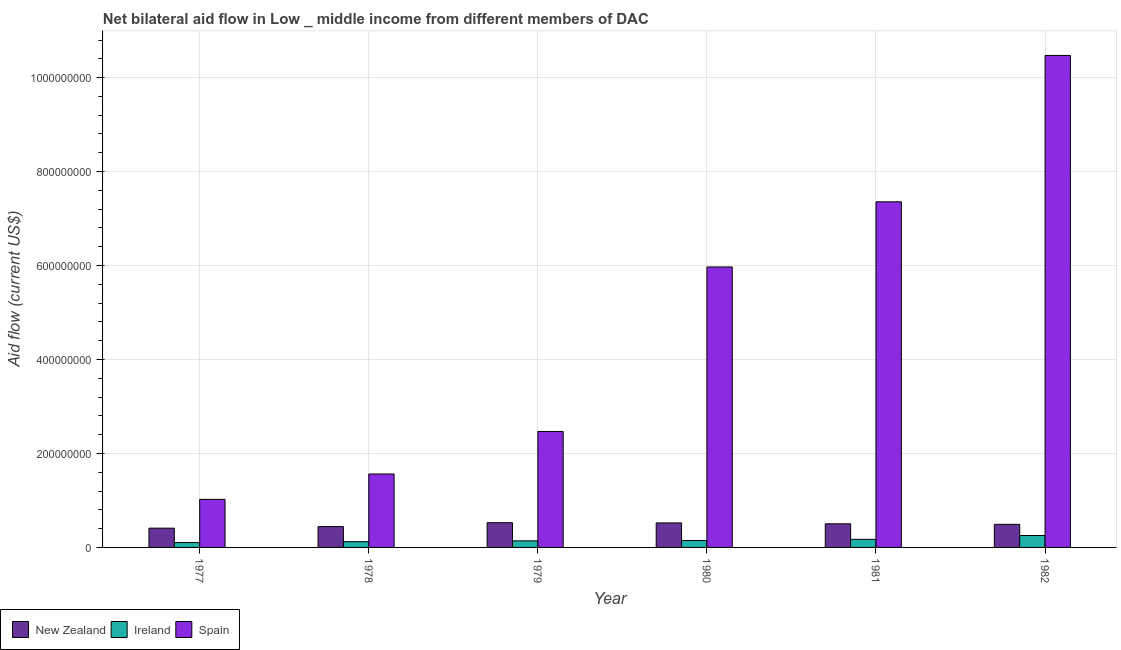How many different coloured bars are there?
Your response must be concise. 3. What is the label of the 5th group of bars from the left?
Offer a very short reply. 1981. What is the amount of aid provided by ireland in 1978?
Your answer should be very brief. 1.22e+07. Across all years, what is the maximum amount of aid provided by new zealand?
Offer a very short reply. 5.27e+07. Across all years, what is the minimum amount of aid provided by new zealand?
Ensure brevity in your answer.  4.10e+07. In which year was the amount of aid provided by new zealand maximum?
Make the answer very short. 1979. What is the total amount of aid provided by ireland in the graph?
Provide a succinct answer. 9.37e+07. What is the difference between the amount of aid provided by ireland in 1979 and that in 1980?
Offer a terse response. -6.70e+05. What is the difference between the amount of aid provided by new zealand in 1981 and the amount of aid provided by ireland in 1979?
Give a very brief answer. -2.37e+06. What is the average amount of aid provided by new zealand per year?
Ensure brevity in your answer.  4.83e+07. What is the ratio of the amount of aid provided by new zealand in 1978 to that in 1980?
Your answer should be compact. 0.85. What is the difference between the highest and the second highest amount of aid provided by new zealand?
Keep it short and to the point. 5.00e+05. What is the difference between the highest and the lowest amount of aid provided by ireland?
Provide a short and direct response. 1.49e+07. How many bars are there?
Ensure brevity in your answer.  18. Are all the bars in the graph horizontal?
Your answer should be very brief. No. How many years are there in the graph?
Ensure brevity in your answer.  6. Are the values on the major ticks of Y-axis written in scientific E-notation?
Keep it short and to the point. No. Does the graph contain grids?
Offer a terse response. Yes. Where does the legend appear in the graph?
Provide a succinct answer. Bottom left. What is the title of the graph?
Provide a succinct answer. Net bilateral aid flow in Low _ middle income from different members of DAC. What is the label or title of the X-axis?
Offer a very short reply. Year. What is the Aid flow (current US$) of New Zealand in 1977?
Offer a terse response. 4.10e+07. What is the Aid flow (current US$) in Ireland in 1977?
Give a very brief answer. 1.04e+07. What is the Aid flow (current US$) of Spain in 1977?
Offer a terse response. 1.02e+08. What is the Aid flow (current US$) in New Zealand in 1978?
Offer a terse response. 4.43e+07. What is the Aid flow (current US$) in Ireland in 1978?
Your answer should be compact. 1.22e+07. What is the Aid flow (current US$) of Spain in 1978?
Ensure brevity in your answer.  1.56e+08. What is the Aid flow (current US$) in New Zealand in 1979?
Give a very brief answer. 5.27e+07. What is the Aid flow (current US$) in Ireland in 1979?
Offer a very short reply. 1.40e+07. What is the Aid flow (current US$) in Spain in 1979?
Your answer should be very brief. 2.47e+08. What is the Aid flow (current US$) of New Zealand in 1980?
Keep it short and to the point. 5.22e+07. What is the Aid flow (current US$) in Ireland in 1980?
Your response must be concise. 1.46e+07. What is the Aid flow (current US$) of Spain in 1980?
Offer a terse response. 5.97e+08. What is the Aid flow (current US$) in New Zealand in 1981?
Provide a short and direct response. 5.03e+07. What is the Aid flow (current US$) in Ireland in 1981?
Your answer should be very brief. 1.72e+07. What is the Aid flow (current US$) of Spain in 1981?
Give a very brief answer. 7.36e+08. What is the Aid flow (current US$) of New Zealand in 1982?
Your response must be concise. 4.91e+07. What is the Aid flow (current US$) in Ireland in 1982?
Your answer should be compact. 2.53e+07. What is the Aid flow (current US$) of Spain in 1982?
Make the answer very short. 1.05e+09. Across all years, what is the maximum Aid flow (current US$) of New Zealand?
Give a very brief answer. 5.27e+07. Across all years, what is the maximum Aid flow (current US$) of Ireland?
Keep it short and to the point. 2.53e+07. Across all years, what is the maximum Aid flow (current US$) in Spain?
Make the answer very short. 1.05e+09. Across all years, what is the minimum Aid flow (current US$) in New Zealand?
Keep it short and to the point. 4.10e+07. Across all years, what is the minimum Aid flow (current US$) in Ireland?
Keep it short and to the point. 1.04e+07. Across all years, what is the minimum Aid flow (current US$) of Spain?
Your answer should be compact. 1.02e+08. What is the total Aid flow (current US$) of New Zealand in the graph?
Provide a short and direct response. 2.90e+08. What is the total Aid flow (current US$) in Ireland in the graph?
Give a very brief answer. 9.37e+07. What is the total Aid flow (current US$) in Spain in the graph?
Keep it short and to the point. 2.89e+09. What is the difference between the Aid flow (current US$) of New Zealand in 1977 and that in 1978?
Your response must be concise. -3.28e+06. What is the difference between the Aid flow (current US$) in Ireland in 1977 and that in 1978?
Ensure brevity in your answer.  -1.87e+06. What is the difference between the Aid flow (current US$) in Spain in 1977 and that in 1978?
Offer a terse response. -5.40e+07. What is the difference between the Aid flow (current US$) of New Zealand in 1977 and that in 1979?
Ensure brevity in your answer.  -1.17e+07. What is the difference between the Aid flow (current US$) in Ireland in 1977 and that in 1979?
Offer a very short reply. -3.61e+06. What is the difference between the Aid flow (current US$) of Spain in 1977 and that in 1979?
Offer a terse response. -1.45e+08. What is the difference between the Aid flow (current US$) in New Zealand in 1977 and that in 1980?
Keep it short and to the point. -1.12e+07. What is the difference between the Aid flow (current US$) in Ireland in 1977 and that in 1980?
Make the answer very short. -4.28e+06. What is the difference between the Aid flow (current US$) in Spain in 1977 and that in 1980?
Offer a terse response. -4.95e+08. What is the difference between the Aid flow (current US$) of New Zealand in 1977 and that in 1981?
Provide a short and direct response. -9.29e+06. What is the difference between the Aid flow (current US$) of Ireland in 1977 and that in 1981?
Offer a very short reply. -6.87e+06. What is the difference between the Aid flow (current US$) of Spain in 1977 and that in 1981?
Provide a short and direct response. -6.33e+08. What is the difference between the Aid flow (current US$) in New Zealand in 1977 and that in 1982?
Provide a succinct answer. -8.13e+06. What is the difference between the Aid flow (current US$) of Ireland in 1977 and that in 1982?
Keep it short and to the point. -1.49e+07. What is the difference between the Aid flow (current US$) in Spain in 1977 and that in 1982?
Offer a very short reply. -9.45e+08. What is the difference between the Aid flow (current US$) of New Zealand in 1978 and that in 1979?
Ensure brevity in your answer.  -8.38e+06. What is the difference between the Aid flow (current US$) of Ireland in 1978 and that in 1979?
Provide a short and direct response. -1.74e+06. What is the difference between the Aid flow (current US$) in Spain in 1978 and that in 1979?
Provide a succinct answer. -9.05e+07. What is the difference between the Aid flow (current US$) of New Zealand in 1978 and that in 1980?
Provide a short and direct response. -7.88e+06. What is the difference between the Aid flow (current US$) of Ireland in 1978 and that in 1980?
Ensure brevity in your answer.  -2.41e+06. What is the difference between the Aid flow (current US$) in Spain in 1978 and that in 1980?
Provide a short and direct response. -4.41e+08. What is the difference between the Aid flow (current US$) in New Zealand in 1978 and that in 1981?
Provide a short and direct response. -6.01e+06. What is the difference between the Aid flow (current US$) in Ireland in 1978 and that in 1981?
Your answer should be very brief. -5.00e+06. What is the difference between the Aid flow (current US$) of Spain in 1978 and that in 1981?
Make the answer very short. -5.79e+08. What is the difference between the Aid flow (current US$) in New Zealand in 1978 and that in 1982?
Offer a terse response. -4.85e+06. What is the difference between the Aid flow (current US$) of Ireland in 1978 and that in 1982?
Give a very brief answer. -1.31e+07. What is the difference between the Aid flow (current US$) in Spain in 1978 and that in 1982?
Keep it short and to the point. -8.91e+08. What is the difference between the Aid flow (current US$) of Ireland in 1979 and that in 1980?
Keep it short and to the point. -6.70e+05. What is the difference between the Aid flow (current US$) in Spain in 1979 and that in 1980?
Give a very brief answer. -3.50e+08. What is the difference between the Aid flow (current US$) of New Zealand in 1979 and that in 1981?
Provide a succinct answer. 2.37e+06. What is the difference between the Aid flow (current US$) in Ireland in 1979 and that in 1981?
Offer a terse response. -3.26e+06. What is the difference between the Aid flow (current US$) in Spain in 1979 and that in 1981?
Keep it short and to the point. -4.89e+08. What is the difference between the Aid flow (current US$) of New Zealand in 1979 and that in 1982?
Make the answer very short. 3.53e+06. What is the difference between the Aid flow (current US$) in Ireland in 1979 and that in 1982?
Your answer should be compact. -1.13e+07. What is the difference between the Aid flow (current US$) of Spain in 1979 and that in 1982?
Offer a terse response. -8.00e+08. What is the difference between the Aid flow (current US$) of New Zealand in 1980 and that in 1981?
Offer a terse response. 1.87e+06. What is the difference between the Aid flow (current US$) of Ireland in 1980 and that in 1981?
Offer a very short reply. -2.59e+06. What is the difference between the Aid flow (current US$) in Spain in 1980 and that in 1981?
Provide a short and direct response. -1.39e+08. What is the difference between the Aid flow (current US$) of New Zealand in 1980 and that in 1982?
Make the answer very short. 3.03e+06. What is the difference between the Aid flow (current US$) in Ireland in 1980 and that in 1982?
Your answer should be compact. -1.07e+07. What is the difference between the Aid flow (current US$) in Spain in 1980 and that in 1982?
Provide a short and direct response. -4.50e+08. What is the difference between the Aid flow (current US$) in New Zealand in 1981 and that in 1982?
Ensure brevity in your answer.  1.16e+06. What is the difference between the Aid flow (current US$) of Ireland in 1981 and that in 1982?
Make the answer very short. -8.07e+06. What is the difference between the Aid flow (current US$) of Spain in 1981 and that in 1982?
Your answer should be compact. -3.12e+08. What is the difference between the Aid flow (current US$) in New Zealand in 1977 and the Aid flow (current US$) in Ireland in 1978?
Ensure brevity in your answer.  2.88e+07. What is the difference between the Aid flow (current US$) in New Zealand in 1977 and the Aid flow (current US$) in Spain in 1978?
Provide a short and direct response. -1.15e+08. What is the difference between the Aid flow (current US$) of Ireland in 1977 and the Aid flow (current US$) of Spain in 1978?
Your response must be concise. -1.46e+08. What is the difference between the Aid flow (current US$) in New Zealand in 1977 and the Aid flow (current US$) in Ireland in 1979?
Your response must be concise. 2.70e+07. What is the difference between the Aid flow (current US$) of New Zealand in 1977 and the Aid flow (current US$) of Spain in 1979?
Provide a short and direct response. -2.06e+08. What is the difference between the Aid flow (current US$) of Ireland in 1977 and the Aid flow (current US$) of Spain in 1979?
Ensure brevity in your answer.  -2.36e+08. What is the difference between the Aid flow (current US$) in New Zealand in 1977 and the Aid flow (current US$) in Ireland in 1980?
Offer a very short reply. 2.64e+07. What is the difference between the Aid flow (current US$) in New Zealand in 1977 and the Aid flow (current US$) in Spain in 1980?
Keep it short and to the point. -5.56e+08. What is the difference between the Aid flow (current US$) of Ireland in 1977 and the Aid flow (current US$) of Spain in 1980?
Your response must be concise. -5.87e+08. What is the difference between the Aid flow (current US$) of New Zealand in 1977 and the Aid flow (current US$) of Ireland in 1981?
Your response must be concise. 2.38e+07. What is the difference between the Aid flow (current US$) in New Zealand in 1977 and the Aid flow (current US$) in Spain in 1981?
Your response must be concise. -6.95e+08. What is the difference between the Aid flow (current US$) in Ireland in 1977 and the Aid flow (current US$) in Spain in 1981?
Provide a short and direct response. -7.25e+08. What is the difference between the Aid flow (current US$) of New Zealand in 1977 and the Aid flow (current US$) of Ireland in 1982?
Give a very brief answer. 1.57e+07. What is the difference between the Aid flow (current US$) in New Zealand in 1977 and the Aid flow (current US$) in Spain in 1982?
Offer a terse response. -1.01e+09. What is the difference between the Aid flow (current US$) in Ireland in 1977 and the Aid flow (current US$) in Spain in 1982?
Ensure brevity in your answer.  -1.04e+09. What is the difference between the Aid flow (current US$) in New Zealand in 1978 and the Aid flow (current US$) in Ireland in 1979?
Your response must be concise. 3.03e+07. What is the difference between the Aid flow (current US$) in New Zealand in 1978 and the Aid flow (current US$) in Spain in 1979?
Make the answer very short. -2.03e+08. What is the difference between the Aid flow (current US$) of Ireland in 1978 and the Aid flow (current US$) of Spain in 1979?
Provide a short and direct response. -2.35e+08. What is the difference between the Aid flow (current US$) in New Zealand in 1978 and the Aid flow (current US$) in Ireland in 1980?
Your answer should be very brief. 2.96e+07. What is the difference between the Aid flow (current US$) in New Zealand in 1978 and the Aid flow (current US$) in Spain in 1980?
Your response must be concise. -5.53e+08. What is the difference between the Aid flow (current US$) in Ireland in 1978 and the Aid flow (current US$) in Spain in 1980?
Your response must be concise. -5.85e+08. What is the difference between the Aid flow (current US$) in New Zealand in 1978 and the Aid flow (current US$) in Ireland in 1981?
Your response must be concise. 2.71e+07. What is the difference between the Aid flow (current US$) of New Zealand in 1978 and the Aid flow (current US$) of Spain in 1981?
Your answer should be compact. -6.91e+08. What is the difference between the Aid flow (current US$) in Ireland in 1978 and the Aid flow (current US$) in Spain in 1981?
Offer a very short reply. -7.23e+08. What is the difference between the Aid flow (current US$) in New Zealand in 1978 and the Aid flow (current US$) in Ireland in 1982?
Your response must be concise. 1.90e+07. What is the difference between the Aid flow (current US$) in New Zealand in 1978 and the Aid flow (current US$) in Spain in 1982?
Make the answer very short. -1.00e+09. What is the difference between the Aid flow (current US$) of Ireland in 1978 and the Aid flow (current US$) of Spain in 1982?
Offer a very short reply. -1.03e+09. What is the difference between the Aid flow (current US$) of New Zealand in 1979 and the Aid flow (current US$) of Ireland in 1980?
Your response must be concise. 3.80e+07. What is the difference between the Aid flow (current US$) in New Zealand in 1979 and the Aid flow (current US$) in Spain in 1980?
Your answer should be compact. -5.44e+08. What is the difference between the Aid flow (current US$) of Ireland in 1979 and the Aid flow (current US$) of Spain in 1980?
Offer a terse response. -5.83e+08. What is the difference between the Aid flow (current US$) of New Zealand in 1979 and the Aid flow (current US$) of Ireland in 1981?
Ensure brevity in your answer.  3.54e+07. What is the difference between the Aid flow (current US$) of New Zealand in 1979 and the Aid flow (current US$) of Spain in 1981?
Provide a short and direct response. -6.83e+08. What is the difference between the Aid flow (current US$) in Ireland in 1979 and the Aid flow (current US$) in Spain in 1981?
Your answer should be compact. -7.22e+08. What is the difference between the Aid flow (current US$) in New Zealand in 1979 and the Aid flow (current US$) in Ireland in 1982?
Your answer should be compact. 2.74e+07. What is the difference between the Aid flow (current US$) in New Zealand in 1979 and the Aid flow (current US$) in Spain in 1982?
Make the answer very short. -9.95e+08. What is the difference between the Aid flow (current US$) of Ireland in 1979 and the Aid flow (current US$) of Spain in 1982?
Your answer should be compact. -1.03e+09. What is the difference between the Aid flow (current US$) in New Zealand in 1980 and the Aid flow (current US$) in Ireland in 1981?
Make the answer very short. 3.49e+07. What is the difference between the Aid flow (current US$) of New Zealand in 1980 and the Aid flow (current US$) of Spain in 1981?
Offer a terse response. -6.83e+08. What is the difference between the Aid flow (current US$) in Ireland in 1980 and the Aid flow (current US$) in Spain in 1981?
Make the answer very short. -7.21e+08. What is the difference between the Aid flow (current US$) of New Zealand in 1980 and the Aid flow (current US$) of Ireland in 1982?
Your answer should be very brief. 2.69e+07. What is the difference between the Aid flow (current US$) of New Zealand in 1980 and the Aid flow (current US$) of Spain in 1982?
Keep it short and to the point. -9.95e+08. What is the difference between the Aid flow (current US$) in Ireland in 1980 and the Aid flow (current US$) in Spain in 1982?
Your answer should be compact. -1.03e+09. What is the difference between the Aid flow (current US$) in New Zealand in 1981 and the Aid flow (current US$) in Ireland in 1982?
Give a very brief answer. 2.50e+07. What is the difference between the Aid flow (current US$) of New Zealand in 1981 and the Aid flow (current US$) of Spain in 1982?
Your answer should be compact. -9.97e+08. What is the difference between the Aid flow (current US$) of Ireland in 1981 and the Aid flow (current US$) of Spain in 1982?
Provide a short and direct response. -1.03e+09. What is the average Aid flow (current US$) in New Zealand per year?
Provide a succinct answer. 4.83e+07. What is the average Aid flow (current US$) in Ireland per year?
Ensure brevity in your answer.  1.56e+07. What is the average Aid flow (current US$) of Spain per year?
Keep it short and to the point. 4.81e+08. In the year 1977, what is the difference between the Aid flow (current US$) of New Zealand and Aid flow (current US$) of Ireland?
Your answer should be compact. 3.06e+07. In the year 1977, what is the difference between the Aid flow (current US$) in New Zealand and Aid flow (current US$) in Spain?
Offer a terse response. -6.13e+07. In the year 1977, what is the difference between the Aid flow (current US$) in Ireland and Aid flow (current US$) in Spain?
Offer a very short reply. -9.20e+07. In the year 1978, what is the difference between the Aid flow (current US$) of New Zealand and Aid flow (current US$) of Ireland?
Offer a terse response. 3.21e+07. In the year 1978, what is the difference between the Aid flow (current US$) of New Zealand and Aid flow (current US$) of Spain?
Your response must be concise. -1.12e+08. In the year 1978, what is the difference between the Aid flow (current US$) in Ireland and Aid flow (current US$) in Spain?
Make the answer very short. -1.44e+08. In the year 1979, what is the difference between the Aid flow (current US$) in New Zealand and Aid flow (current US$) in Ireland?
Provide a succinct answer. 3.87e+07. In the year 1979, what is the difference between the Aid flow (current US$) in New Zealand and Aid flow (current US$) in Spain?
Provide a succinct answer. -1.94e+08. In the year 1979, what is the difference between the Aid flow (current US$) in Ireland and Aid flow (current US$) in Spain?
Provide a succinct answer. -2.33e+08. In the year 1980, what is the difference between the Aid flow (current US$) of New Zealand and Aid flow (current US$) of Ireland?
Your response must be concise. 3.75e+07. In the year 1980, what is the difference between the Aid flow (current US$) of New Zealand and Aid flow (current US$) of Spain?
Offer a terse response. -5.45e+08. In the year 1980, what is the difference between the Aid flow (current US$) of Ireland and Aid flow (current US$) of Spain?
Give a very brief answer. -5.82e+08. In the year 1981, what is the difference between the Aid flow (current US$) of New Zealand and Aid flow (current US$) of Ireland?
Keep it short and to the point. 3.31e+07. In the year 1981, what is the difference between the Aid flow (current US$) in New Zealand and Aid flow (current US$) in Spain?
Give a very brief answer. -6.85e+08. In the year 1981, what is the difference between the Aid flow (current US$) in Ireland and Aid flow (current US$) in Spain?
Your answer should be compact. -7.18e+08. In the year 1982, what is the difference between the Aid flow (current US$) in New Zealand and Aid flow (current US$) in Ireland?
Your response must be concise. 2.38e+07. In the year 1982, what is the difference between the Aid flow (current US$) in New Zealand and Aid flow (current US$) in Spain?
Your response must be concise. -9.98e+08. In the year 1982, what is the difference between the Aid flow (current US$) in Ireland and Aid flow (current US$) in Spain?
Offer a very short reply. -1.02e+09. What is the ratio of the Aid flow (current US$) in New Zealand in 1977 to that in 1978?
Provide a succinct answer. 0.93. What is the ratio of the Aid flow (current US$) in Ireland in 1977 to that in 1978?
Give a very brief answer. 0.85. What is the ratio of the Aid flow (current US$) in Spain in 1977 to that in 1978?
Give a very brief answer. 0.65. What is the ratio of the Aid flow (current US$) of New Zealand in 1977 to that in 1979?
Give a very brief answer. 0.78. What is the ratio of the Aid flow (current US$) in Ireland in 1977 to that in 1979?
Your response must be concise. 0.74. What is the ratio of the Aid flow (current US$) in Spain in 1977 to that in 1979?
Keep it short and to the point. 0.41. What is the ratio of the Aid flow (current US$) in New Zealand in 1977 to that in 1980?
Your response must be concise. 0.79. What is the ratio of the Aid flow (current US$) of Ireland in 1977 to that in 1980?
Offer a terse response. 0.71. What is the ratio of the Aid flow (current US$) of Spain in 1977 to that in 1980?
Your answer should be compact. 0.17. What is the ratio of the Aid flow (current US$) in New Zealand in 1977 to that in 1981?
Provide a succinct answer. 0.82. What is the ratio of the Aid flow (current US$) in Ireland in 1977 to that in 1981?
Your answer should be very brief. 0.6. What is the ratio of the Aid flow (current US$) in Spain in 1977 to that in 1981?
Give a very brief answer. 0.14. What is the ratio of the Aid flow (current US$) in New Zealand in 1977 to that in 1982?
Your answer should be compact. 0.83. What is the ratio of the Aid flow (current US$) of Ireland in 1977 to that in 1982?
Ensure brevity in your answer.  0.41. What is the ratio of the Aid flow (current US$) of Spain in 1977 to that in 1982?
Give a very brief answer. 0.1. What is the ratio of the Aid flow (current US$) of New Zealand in 1978 to that in 1979?
Provide a succinct answer. 0.84. What is the ratio of the Aid flow (current US$) in Ireland in 1978 to that in 1979?
Your answer should be compact. 0.88. What is the ratio of the Aid flow (current US$) of Spain in 1978 to that in 1979?
Your answer should be compact. 0.63. What is the ratio of the Aid flow (current US$) in New Zealand in 1978 to that in 1980?
Your answer should be compact. 0.85. What is the ratio of the Aid flow (current US$) of Ireland in 1978 to that in 1980?
Offer a very short reply. 0.84. What is the ratio of the Aid flow (current US$) in Spain in 1978 to that in 1980?
Your response must be concise. 0.26. What is the ratio of the Aid flow (current US$) in New Zealand in 1978 to that in 1981?
Offer a very short reply. 0.88. What is the ratio of the Aid flow (current US$) in Ireland in 1978 to that in 1981?
Offer a very short reply. 0.71. What is the ratio of the Aid flow (current US$) in Spain in 1978 to that in 1981?
Offer a very short reply. 0.21. What is the ratio of the Aid flow (current US$) in New Zealand in 1978 to that in 1982?
Keep it short and to the point. 0.9. What is the ratio of the Aid flow (current US$) in Ireland in 1978 to that in 1982?
Make the answer very short. 0.48. What is the ratio of the Aid flow (current US$) in Spain in 1978 to that in 1982?
Your answer should be compact. 0.15. What is the ratio of the Aid flow (current US$) of New Zealand in 1979 to that in 1980?
Provide a succinct answer. 1.01. What is the ratio of the Aid flow (current US$) in Ireland in 1979 to that in 1980?
Your answer should be compact. 0.95. What is the ratio of the Aid flow (current US$) of Spain in 1979 to that in 1980?
Give a very brief answer. 0.41. What is the ratio of the Aid flow (current US$) of New Zealand in 1979 to that in 1981?
Your answer should be very brief. 1.05. What is the ratio of the Aid flow (current US$) of Ireland in 1979 to that in 1981?
Make the answer very short. 0.81. What is the ratio of the Aid flow (current US$) in Spain in 1979 to that in 1981?
Your response must be concise. 0.34. What is the ratio of the Aid flow (current US$) in New Zealand in 1979 to that in 1982?
Your answer should be very brief. 1.07. What is the ratio of the Aid flow (current US$) in Ireland in 1979 to that in 1982?
Provide a short and direct response. 0.55. What is the ratio of the Aid flow (current US$) in Spain in 1979 to that in 1982?
Give a very brief answer. 0.24. What is the ratio of the Aid flow (current US$) of New Zealand in 1980 to that in 1981?
Provide a succinct answer. 1.04. What is the ratio of the Aid flow (current US$) of Ireland in 1980 to that in 1981?
Your answer should be compact. 0.85. What is the ratio of the Aid flow (current US$) in Spain in 1980 to that in 1981?
Your answer should be compact. 0.81. What is the ratio of the Aid flow (current US$) of New Zealand in 1980 to that in 1982?
Your answer should be compact. 1.06. What is the ratio of the Aid flow (current US$) in Ireland in 1980 to that in 1982?
Your answer should be very brief. 0.58. What is the ratio of the Aid flow (current US$) of Spain in 1980 to that in 1982?
Your answer should be compact. 0.57. What is the ratio of the Aid flow (current US$) of New Zealand in 1981 to that in 1982?
Keep it short and to the point. 1.02. What is the ratio of the Aid flow (current US$) of Ireland in 1981 to that in 1982?
Offer a terse response. 0.68. What is the ratio of the Aid flow (current US$) in Spain in 1981 to that in 1982?
Make the answer very short. 0.7. What is the difference between the highest and the second highest Aid flow (current US$) of Ireland?
Keep it short and to the point. 8.07e+06. What is the difference between the highest and the second highest Aid flow (current US$) in Spain?
Give a very brief answer. 3.12e+08. What is the difference between the highest and the lowest Aid flow (current US$) in New Zealand?
Offer a terse response. 1.17e+07. What is the difference between the highest and the lowest Aid flow (current US$) of Ireland?
Keep it short and to the point. 1.49e+07. What is the difference between the highest and the lowest Aid flow (current US$) of Spain?
Your answer should be compact. 9.45e+08. 